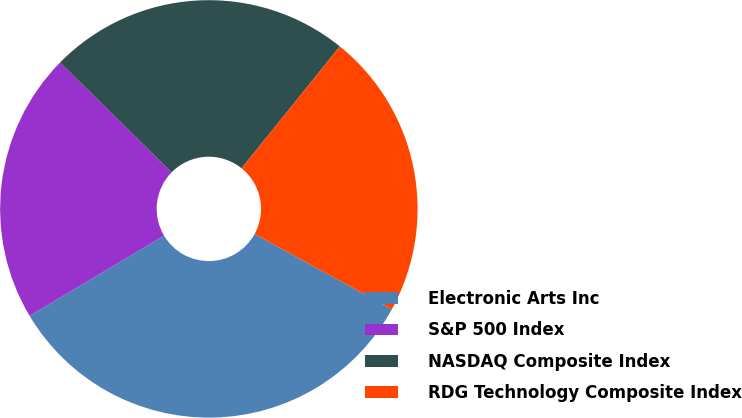<chart> <loc_0><loc_0><loc_500><loc_500><pie_chart><fcel>Electronic Arts Inc<fcel>S&P 500 Index<fcel>NASDAQ Composite Index<fcel>RDG Technology Composite Index<nl><fcel>33.46%<fcel>20.93%<fcel>23.43%<fcel>22.18%<nl></chart> 